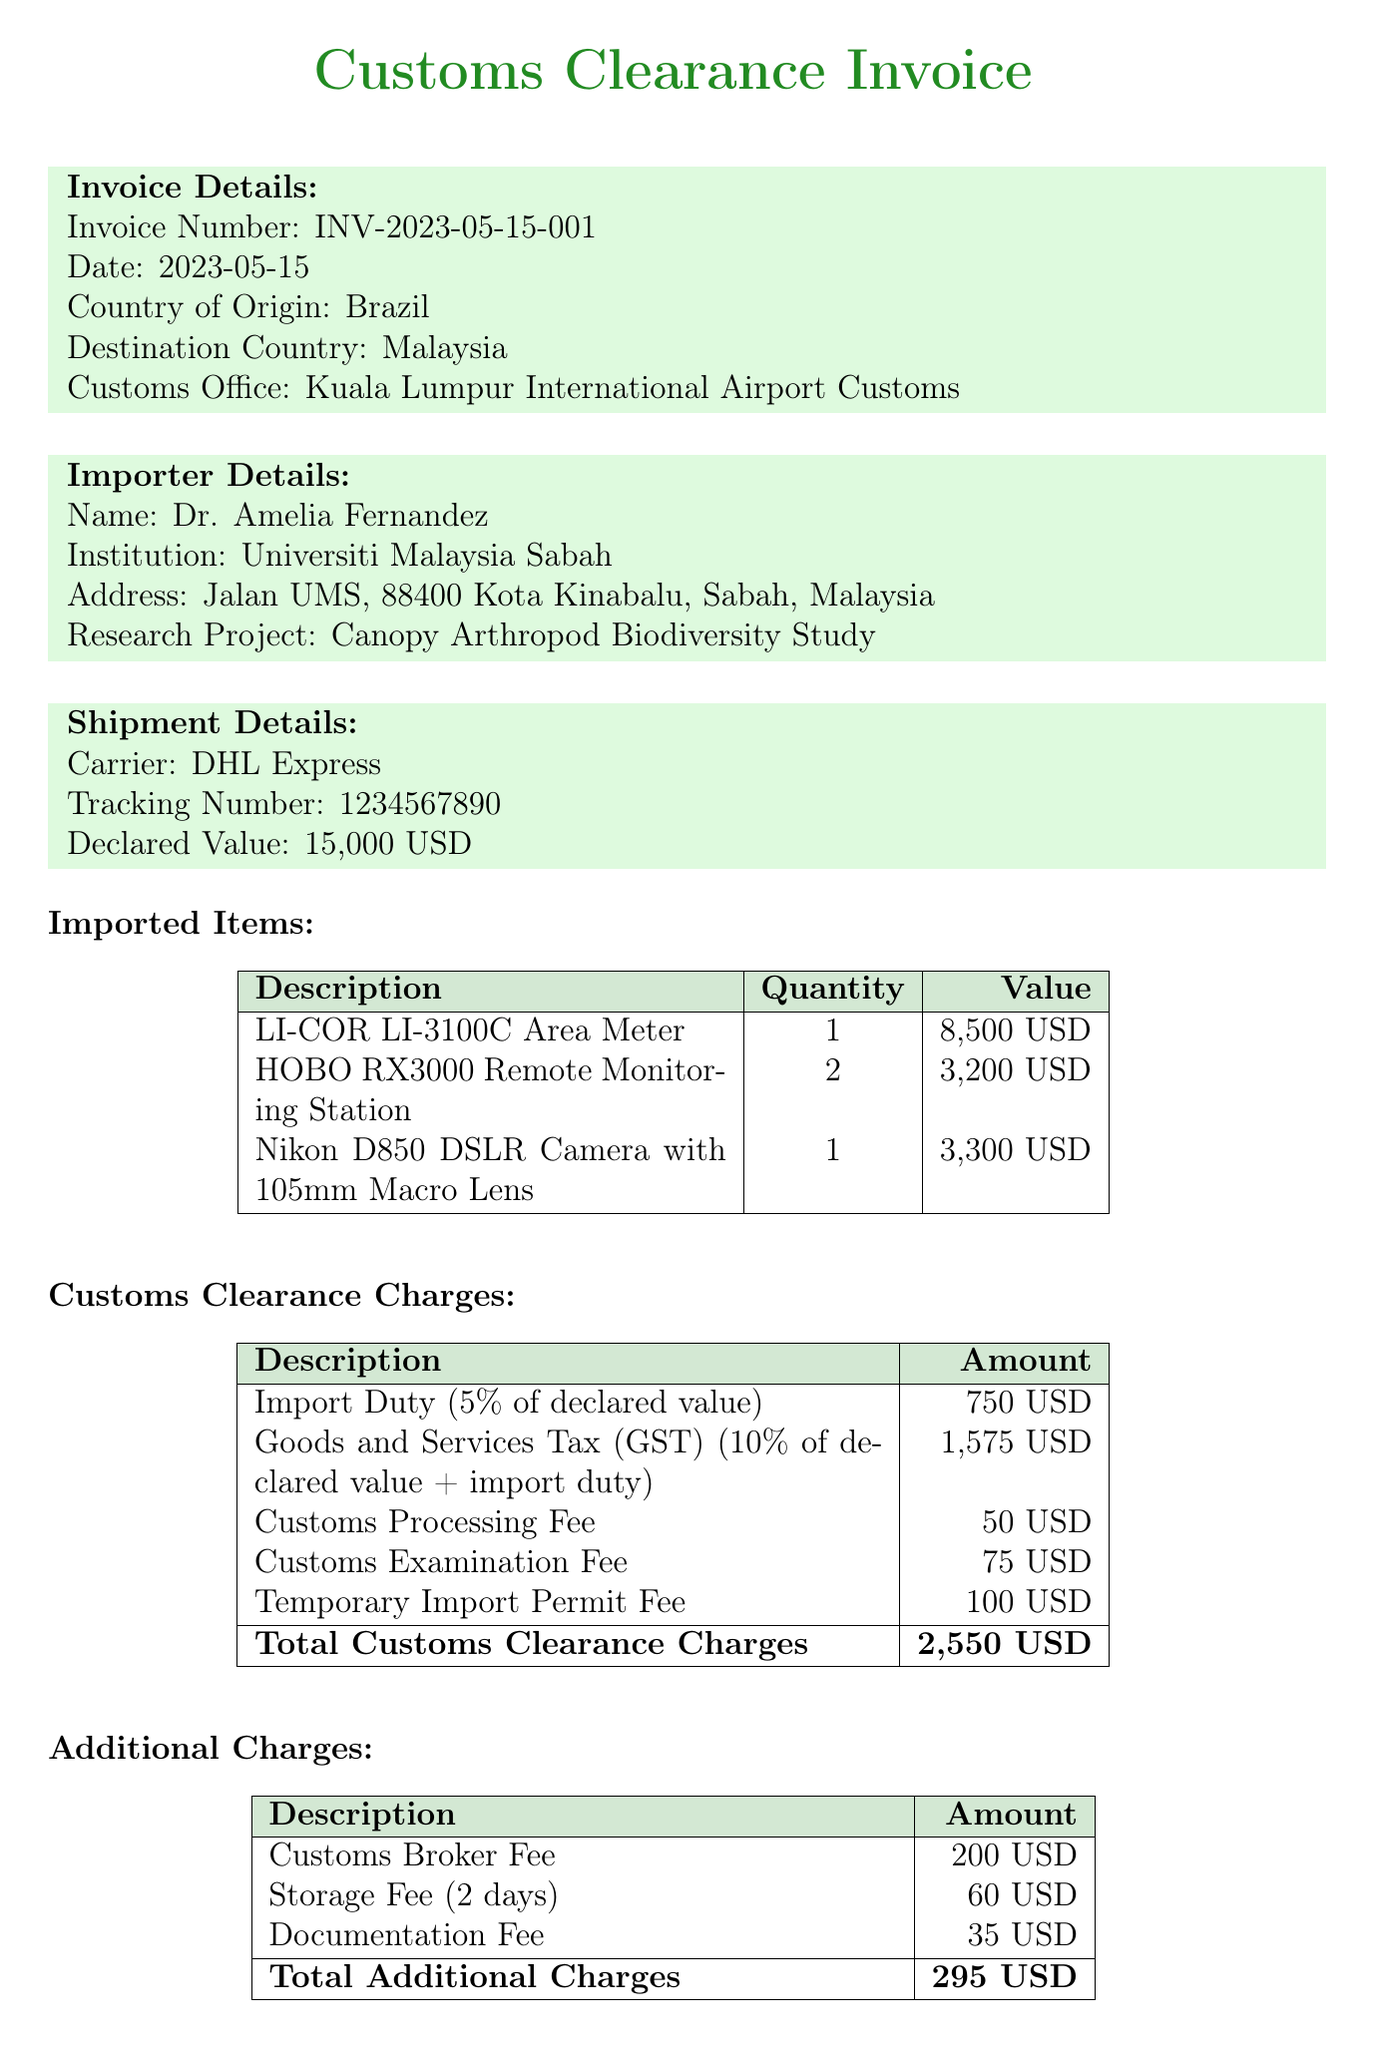What is the invoice number? The invoice number is uniquely assigned to the document for tracking purposes.
Answer: INV-2023-05-15-001 Who is the importer? The importer is the individual or organization receiving the shipment and is specified in the document.
Answer: Dr. Amelia Fernandez What is the declared value of the shipment? The declared value represents the total value of the items being imported, as stated in the document.
Answer: 15,000 USD What is the total amount of customs clearance charges? The total customs clearance charges are the sum of all individual customs-related fees listed in the document.
Answer: 2,550 USD How much is the Goods and Services Tax (GST)? The GST is a specific tax charge applied to the declared value and import duty of the goods.
Answer: 1,575 USD What is the total grand amount due? The grand total is the overall cost that needs to be settled, including all charges listed on the invoice.
Answer: 2,845 USD What is the payment due date? The payment due date indicates when the payment should be completed to avoid penalties.
Answer: 2023-05-30 Which customs office is mentioned in the document? The customs office is the location where the customs clearance process takes place and is noted in the invoice.
Answer: Kuala Lumpur International Airport Customs What is the carrier for this shipment? The carrier is the service company responsible for transporting the items, which is indicated in the document.
Answer: DHL Express 